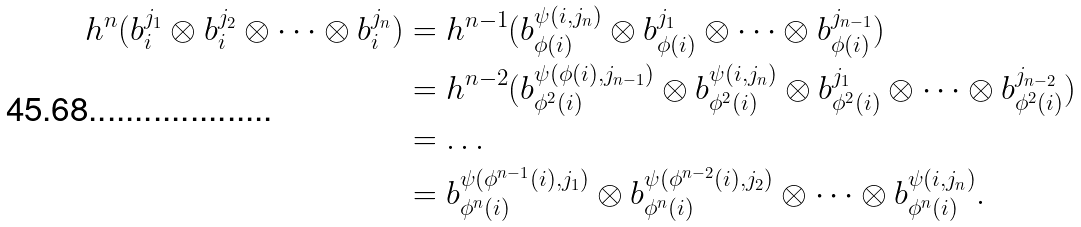<formula> <loc_0><loc_0><loc_500><loc_500>h ^ { n } ( b _ { i } ^ { j _ { 1 } } \otimes b _ { i } ^ { j _ { 2 } } \otimes \dots \otimes b _ { i } ^ { j _ { n } } ) & = h ^ { n - 1 } ( b _ { \phi ( i ) } ^ { \psi ( i , j _ { n } ) } \otimes b _ { \phi ( i ) } ^ { j _ { 1 } } \otimes \dots \otimes b _ { \phi ( i ) } ^ { j _ { n - 1 } } ) \\ & = h ^ { n - 2 } ( b _ { \phi ^ { 2 } ( i ) } ^ { \psi ( \phi ( i ) , j _ { n - 1 } ) } \otimes b _ { \phi ^ { 2 } ( i ) } ^ { \psi ( i , j _ { n } ) } \otimes b _ { \phi ^ { 2 } ( i ) } ^ { j _ { 1 } } \otimes \dots \otimes b _ { \phi ^ { 2 } ( i ) } ^ { j _ { n - 2 } } ) \\ & = \dots \\ & = b _ { \phi ^ { n } ( i ) } ^ { \psi ( \phi ^ { n - 1 } ( i ) , j _ { 1 } ) } \otimes b _ { \phi ^ { n } ( i ) } ^ { \psi ( \phi ^ { n - 2 } ( i ) , j _ { 2 } ) } \otimes \dots \otimes b _ { \phi ^ { n } ( i ) } ^ { \psi ( i , j _ { n } ) } .</formula> 